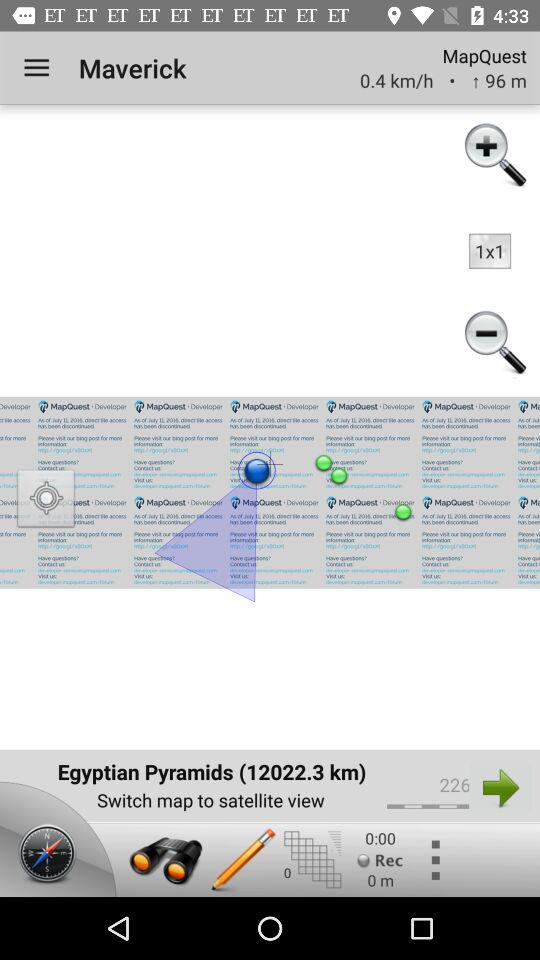What is the application name? The application name is "Maverick". 